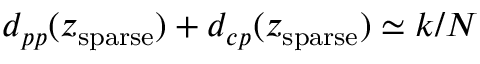<formula> <loc_0><loc_0><loc_500><loc_500>d _ { p p } ( z _ { s p a r s e } ) + d _ { c p } ( z _ { s p a r s e } ) \simeq k / N</formula> 